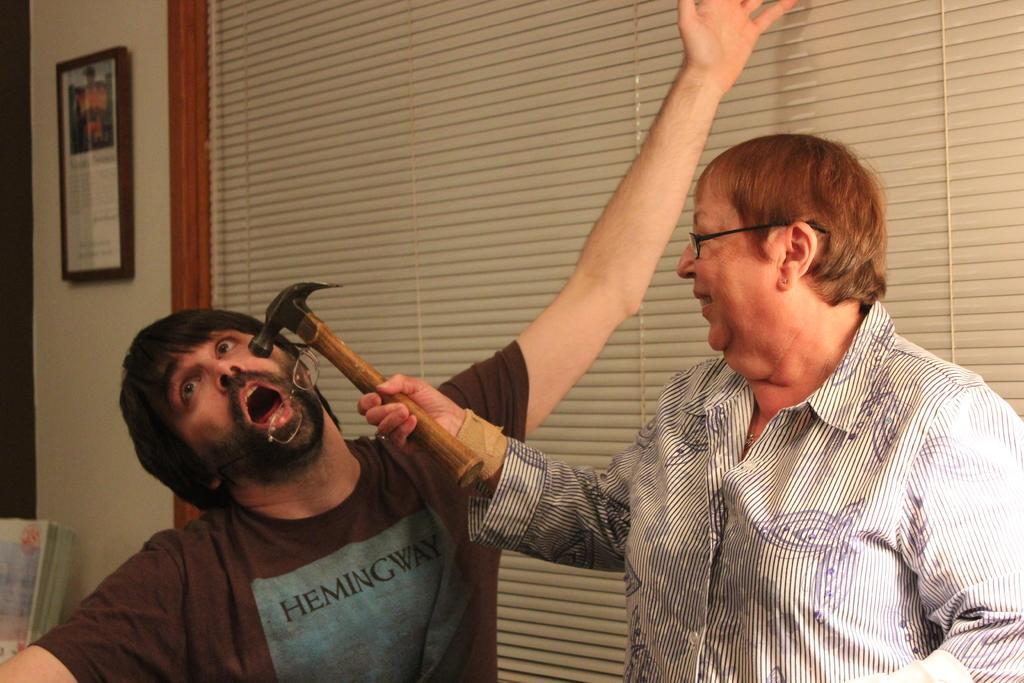How would you summarize this image in a sentence or two? In this image I can see two persons, the person at right wearing white shirt holding hammer and the person at left wearing black shirt, at the back I can see wall in white color and a frame attached to it. 